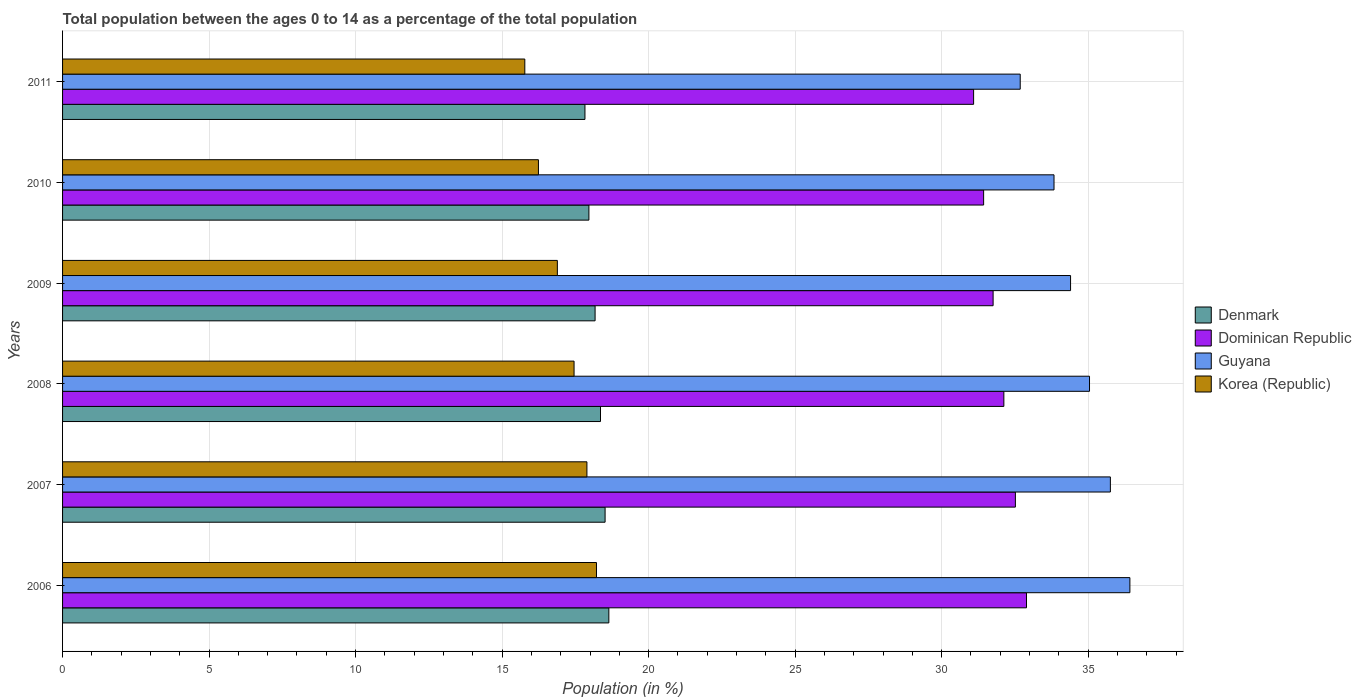Are the number of bars per tick equal to the number of legend labels?
Give a very brief answer. Yes. Are the number of bars on each tick of the Y-axis equal?
Your answer should be very brief. Yes. How many bars are there on the 6th tick from the bottom?
Your response must be concise. 4. What is the percentage of the population ages 0 to 14 in Denmark in 2010?
Make the answer very short. 17.96. Across all years, what is the maximum percentage of the population ages 0 to 14 in Korea (Republic)?
Provide a succinct answer. 18.22. Across all years, what is the minimum percentage of the population ages 0 to 14 in Guyana?
Provide a short and direct response. 32.68. What is the total percentage of the population ages 0 to 14 in Guyana in the graph?
Provide a short and direct response. 208.15. What is the difference between the percentage of the population ages 0 to 14 in Korea (Republic) in 2007 and that in 2010?
Provide a succinct answer. 1.65. What is the difference between the percentage of the population ages 0 to 14 in Dominican Republic in 2010 and the percentage of the population ages 0 to 14 in Korea (Republic) in 2007?
Provide a short and direct response. 13.54. What is the average percentage of the population ages 0 to 14 in Dominican Republic per year?
Your answer should be very brief. 31.97. In the year 2011, what is the difference between the percentage of the population ages 0 to 14 in Denmark and percentage of the population ages 0 to 14 in Guyana?
Keep it short and to the point. -14.85. In how many years, is the percentage of the population ages 0 to 14 in Guyana greater than 1 ?
Your answer should be very brief. 6. What is the ratio of the percentage of the population ages 0 to 14 in Korea (Republic) in 2007 to that in 2010?
Provide a short and direct response. 1.1. Is the difference between the percentage of the population ages 0 to 14 in Denmark in 2008 and 2010 greater than the difference between the percentage of the population ages 0 to 14 in Guyana in 2008 and 2010?
Keep it short and to the point. No. What is the difference between the highest and the second highest percentage of the population ages 0 to 14 in Denmark?
Offer a very short reply. 0.13. What is the difference between the highest and the lowest percentage of the population ages 0 to 14 in Dominican Republic?
Keep it short and to the point. 1.8. In how many years, is the percentage of the population ages 0 to 14 in Korea (Republic) greater than the average percentage of the population ages 0 to 14 in Korea (Republic) taken over all years?
Your response must be concise. 3. Is the sum of the percentage of the population ages 0 to 14 in Denmark in 2006 and 2007 greater than the maximum percentage of the population ages 0 to 14 in Guyana across all years?
Your answer should be very brief. Yes. What does the 1st bar from the top in 2009 represents?
Keep it short and to the point. Korea (Republic). What does the 2nd bar from the bottom in 2009 represents?
Your answer should be very brief. Dominican Republic. Is it the case that in every year, the sum of the percentage of the population ages 0 to 14 in Dominican Republic and percentage of the population ages 0 to 14 in Denmark is greater than the percentage of the population ages 0 to 14 in Korea (Republic)?
Your response must be concise. Yes. How many years are there in the graph?
Provide a short and direct response. 6. What is the difference between two consecutive major ticks on the X-axis?
Your answer should be compact. 5. Does the graph contain any zero values?
Offer a very short reply. No. Where does the legend appear in the graph?
Provide a succinct answer. Center right. How are the legend labels stacked?
Provide a short and direct response. Vertical. What is the title of the graph?
Offer a very short reply. Total population between the ages 0 to 14 as a percentage of the total population. Does "Middle East & North Africa (all income levels)" appear as one of the legend labels in the graph?
Provide a short and direct response. No. What is the label or title of the Y-axis?
Provide a short and direct response. Years. What is the Population (in %) in Denmark in 2006?
Ensure brevity in your answer.  18.64. What is the Population (in %) in Dominican Republic in 2006?
Your response must be concise. 32.9. What is the Population (in %) in Guyana in 2006?
Your answer should be very brief. 36.42. What is the Population (in %) in Korea (Republic) in 2006?
Provide a succinct answer. 18.22. What is the Population (in %) of Denmark in 2007?
Your answer should be compact. 18.52. What is the Population (in %) in Dominican Republic in 2007?
Your answer should be very brief. 32.52. What is the Population (in %) in Guyana in 2007?
Keep it short and to the point. 35.76. What is the Population (in %) in Korea (Republic) in 2007?
Ensure brevity in your answer.  17.89. What is the Population (in %) of Denmark in 2008?
Offer a very short reply. 18.36. What is the Population (in %) in Dominican Republic in 2008?
Give a very brief answer. 32.12. What is the Population (in %) of Guyana in 2008?
Give a very brief answer. 35.05. What is the Population (in %) in Korea (Republic) in 2008?
Offer a terse response. 17.46. What is the Population (in %) in Denmark in 2009?
Your answer should be very brief. 18.17. What is the Population (in %) in Dominican Republic in 2009?
Offer a terse response. 31.76. What is the Population (in %) in Guyana in 2009?
Provide a short and direct response. 34.4. What is the Population (in %) of Korea (Republic) in 2009?
Your response must be concise. 16.89. What is the Population (in %) of Denmark in 2010?
Your response must be concise. 17.96. What is the Population (in %) in Dominican Republic in 2010?
Provide a succinct answer. 31.43. What is the Population (in %) of Guyana in 2010?
Offer a terse response. 33.83. What is the Population (in %) of Korea (Republic) in 2010?
Ensure brevity in your answer.  16.24. What is the Population (in %) of Denmark in 2011?
Your answer should be compact. 17.83. What is the Population (in %) of Dominican Republic in 2011?
Your answer should be compact. 31.09. What is the Population (in %) of Guyana in 2011?
Ensure brevity in your answer.  32.68. What is the Population (in %) of Korea (Republic) in 2011?
Offer a very short reply. 15.77. Across all years, what is the maximum Population (in %) of Denmark?
Your response must be concise. 18.64. Across all years, what is the maximum Population (in %) of Dominican Republic?
Ensure brevity in your answer.  32.9. Across all years, what is the maximum Population (in %) in Guyana?
Offer a terse response. 36.42. Across all years, what is the maximum Population (in %) in Korea (Republic)?
Provide a succinct answer. 18.22. Across all years, what is the minimum Population (in %) of Denmark?
Offer a very short reply. 17.83. Across all years, what is the minimum Population (in %) in Dominican Republic?
Offer a terse response. 31.09. Across all years, what is the minimum Population (in %) in Guyana?
Offer a very short reply. 32.68. Across all years, what is the minimum Population (in %) of Korea (Republic)?
Keep it short and to the point. 15.77. What is the total Population (in %) of Denmark in the graph?
Ensure brevity in your answer.  109.48. What is the total Population (in %) in Dominican Republic in the graph?
Provide a short and direct response. 191.82. What is the total Population (in %) of Guyana in the graph?
Give a very brief answer. 208.15. What is the total Population (in %) in Korea (Republic) in the graph?
Make the answer very short. 102.47. What is the difference between the Population (in %) in Denmark in 2006 and that in 2007?
Provide a succinct answer. 0.13. What is the difference between the Population (in %) of Dominican Republic in 2006 and that in 2007?
Provide a succinct answer. 0.38. What is the difference between the Population (in %) of Guyana in 2006 and that in 2007?
Keep it short and to the point. 0.67. What is the difference between the Population (in %) of Korea (Republic) in 2006 and that in 2007?
Make the answer very short. 0.33. What is the difference between the Population (in %) of Denmark in 2006 and that in 2008?
Offer a very short reply. 0.28. What is the difference between the Population (in %) in Dominican Republic in 2006 and that in 2008?
Give a very brief answer. 0.77. What is the difference between the Population (in %) in Guyana in 2006 and that in 2008?
Ensure brevity in your answer.  1.38. What is the difference between the Population (in %) of Korea (Republic) in 2006 and that in 2008?
Your response must be concise. 0.77. What is the difference between the Population (in %) of Denmark in 2006 and that in 2009?
Provide a short and direct response. 0.47. What is the difference between the Population (in %) of Dominican Republic in 2006 and that in 2009?
Ensure brevity in your answer.  1.14. What is the difference between the Population (in %) in Guyana in 2006 and that in 2009?
Your response must be concise. 2.02. What is the difference between the Population (in %) of Korea (Republic) in 2006 and that in 2009?
Provide a succinct answer. 1.34. What is the difference between the Population (in %) in Denmark in 2006 and that in 2010?
Your answer should be very brief. 0.68. What is the difference between the Population (in %) of Dominican Republic in 2006 and that in 2010?
Your response must be concise. 1.46. What is the difference between the Population (in %) in Guyana in 2006 and that in 2010?
Your answer should be very brief. 2.59. What is the difference between the Population (in %) in Korea (Republic) in 2006 and that in 2010?
Provide a short and direct response. 1.98. What is the difference between the Population (in %) of Denmark in 2006 and that in 2011?
Provide a succinct answer. 0.81. What is the difference between the Population (in %) in Dominican Republic in 2006 and that in 2011?
Make the answer very short. 1.8. What is the difference between the Population (in %) in Guyana in 2006 and that in 2011?
Your response must be concise. 3.74. What is the difference between the Population (in %) of Korea (Republic) in 2006 and that in 2011?
Your answer should be very brief. 2.45. What is the difference between the Population (in %) of Denmark in 2007 and that in 2008?
Keep it short and to the point. 0.16. What is the difference between the Population (in %) of Dominican Republic in 2007 and that in 2008?
Your answer should be very brief. 0.39. What is the difference between the Population (in %) in Guyana in 2007 and that in 2008?
Ensure brevity in your answer.  0.71. What is the difference between the Population (in %) of Korea (Republic) in 2007 and that in 2008?
Your answer should be compact. 0.44. What is the difference between the Population (in %) of Denmark in 2007 and that in 2009?
Provide a succinct answer. 0.34. What is the difference between the Population (in %) of Dominican Republic in 2007 and that in 2009?
Ensure brevity in your answer.  0.76. What is the difference between the Population (in %) of Guyana in 2007 and that in 2009?
Provide a succinct answer. 1.36. What is the difference between the Population (in %) in Korea (Republic) in 2007 and that in 2009?
Ensure brevity in your answer.  1.01. What is the difference between the Population (in %) of Denmark in 2007 and that in 2010?
Offer a very short reply. 0.55. What is the difference between the Population (in %) in Dominican Republic in 2007 and that in 2010?
Give a very brief answer. 1.08. What is the difference between the Population (in %) of Guyana in 2007 and that in 2010?
Your answer should be compact. 1.92. What is the difference between the Population (in %) of Korea (Republic) in 2007 and that in 2010?
Provide a short and direct response. 1.65. What is the difference between the Population (in %) of Denmark in 2007 and that in 2011?
Your answer should be very brief. 0.69. What is the difference between the Population (in %) of Dominican Republic in 2007 and that in 2011?
Make the answer very short. 1.43. What is the difference between the Population (in %) of Guyana in 2007 and that in 2011?
Your response must be concise. 3.08. What is the difference between the Population (in %) in Korea (Republic) in 2007 and that in 2011?
Offer a very short reply. 2.12. What is the difference between the Population (in %) in Denmark in 2008 and that in 2009?
Offer a terse response. 0.18. What is the difference between the Population (in %) in Dominican Republic in 2008 and that in 2009?
Give a very brief answer. 0.37. What is the difference between the Population (in %) of Guyana in 2008 and that in 2009?
Give a very brief answer. 0.65. What is the difference between the Population (in %) of Korea (Republic) in 2008 and that in 2009?
Make the answer very short. 0.57. What is the difference between the Population (in %) in Denmark in 2008 and that in 2010?
Give a very brief answer. 0.4. What is the difference between the Population (in %) of Dominican Republic in 2008 and that in 2010?
Offer a very short reply. 0.69. What is the difference between the Population (in %) in Guyana in 2008 and that in 2010?
Offer a terse response. 1.21. What is the difference between the Population (in %) of Korea (Republic) in 2008 and that in 2010?
Make the answer very short. 1.22. What is the difference between the Population (in %) of Denmark in 2008 and that in 2011?
Ensure brevity in your answer.  0.53. What is the difference between the Population (in %) of Dominican Republic in 2008 and that in 2011?
Give a very brief answer. 1.03. What is the difference between the Population (in %) of Guyana in 2008 and that in 2011?
Provide a short and direct response. 2.36. What is the difference between the Population (in %) in Korea (Republic) in 2008 and that in 2011?
Your response must be concise. 1.68. What is the difference between the Population (in %) of Denmark in 2009 and that in 2010?
Your answer should be very brief. 0.21. What is the difference between the Population (in %) in Dominican Republic in 2009 and that in 2010?
Keep it short and to the point. 0.32. What is the difference between the Population (in %) of Guyana in 2009 and that in 2010?
Offer a terse response. 0.57. What is the difference between the Population (in %) of Korea (Republic) in 2009 and that in 2010?
Offer a very short reply. 0.65. What is the difference between the Population (in %) of Denmark in 2009 and that in 2011?
Your answer should be very brief. 0.35. What is the difference between the Population (in %) in Dominican Republic in 2009 and that in 2011?
Your response must be concise. 0.67. What is the difference between the Population (in %) of Guyana in 2009 and that in 2011?
Give a very brief answer. 1.72. What is the difference between the Population (in %) in Korea (Republic) in 2009 and that in 2011?
Your answer should be compact. 1.11. What is the difference between the Population (in %) in Denmark in 2010 and that in 2011?
Give a very brief answer. 0.13. What is the difference between the Population (in %) of Dominican Republic in 2010 and that in 2011?
Offer a terse response. 0.34. What is the difference between the Population (in %) in Guyana in 2010 and that in 2011?
Offer a very short reply. 1.15. What is the difference between the Population (in %) of Korea (Republic) in 2010 and that in 2011?
Provide a succinct answer. 0.47. What is the difference between the Population (in %) in Denmark in 2006 and the Population (in %) in Dominican Republic in 2007?
Offer a very short reply. -13.87. What is the difference between the Population (in %) of Denmark in 2006 and the Population (in %) of Guyana in 2007?
Provide a succinct answer. -17.12. What is the difference between the Population (in %) of Denmark in 2006 and the Population (in %) of Korea (Republic) in 2007?
Give a very brief answer. 0.75. What is the difference between the Population (in %) in Dominican Republic in 2006 and the Population (in %) in Guyana in 2007?
Make the answer very short. -2.86. What is the difference between the Population (in %) of Dominican Republic in 2006 and the Population (in %) of Korea (Republic) in 2007?
Ensure brevity in your answer.  15. What is the difference between the Population (in %) in Guyana in 2006 and the Population (in %) in Korea (Republic) in 2007?
Provide a succinct answer. 18.53. What is the difference between the Population (in %) of Denmark in 2006 and the Population (in %) of Dominican Republic in 2008?
Make the answer very short. -13.48. What is the difference between the Population (in %) of Denmark in 2006 and the Population (in %) of Guyana in 2008?
Your answer should be very brief. -16.4. What is the difference between the Population (in %) of Denmark in 2006 and the Population (in %) of Korea (Republic) in 2008?
Your answer should be very brief. 1.19. What is the difference between the Population (in %) of Dominican Republic in 2006 and the Population (in %) of Guyana in 2008?
Offer a terse response. -2.15. What is the difference between the Population (in %) in Dominican Republic in 2006 and the Population (in %) in Korea (Republic) in 2008?
Offer a terse response. 15.44. What is the difference between the Population (in %) in Guyana in 2006 and the Population (in %) in Korea (Republic) in 2008?
Make the answer very short. 18.97. What is the difference between the Population (in %) in Denmark in 2006 and the Population (in %) in Dominican Republic in 2009?
Ensure brevity in your answer.  -13.11. What is the difference between the Population (in %) of Denmark in 2006 and the Population (in %) of Guyana in 2009?
Offer a very short reply. -15.76. What is the difference between the Population (in %) of Denmark in 2006 and the Population (in %) of Korea (Republic) in 2009?
Your answer should be very brief. 1.76. What is the difference between the Population (in %) in Dominican Republic in 2006 and the Population (in %) in Guyana in 2009?
Provide a succinct answer. -1.5. What is the difference between the Population (in %) in Dominican Republic in 2006 and the Population (in %) in Korea (Republic) in 2009?
Provide a short and direct response. 16.01. What is the difference between the Population (in %) of Guyana in 2006 and the Population (in %) of Korea (Republic) in 2009?
Offer a very short reply. 19.54. What is the difference between the Population (in %) of Denmark in 2006 and the Population (in %) of Dominican Republic in 2010?
Your response must be concise. -12.79. What is the difference between the Population (in %) of Denmark in 2006 and the Population (in %) of Guyana in 2010?
Make the answer very short. -15.19. What is the difference between the Population (in %) in Denmark in 2006 and the Population (in %) in Korea (Republic) in 2010?
Your answer should be compact. 2.4. What is the difference between the Population (in %) in Dominican Republic in 2006 and the Population (in %) in Guyana in 2010?
Your answer should be very brief. -0.94. What is the difference between the Population (in %) of Dominican Republic in 2006 and the Population (in %) of Korea (Republic) in 2010?
Your answer should be very brief. 16.66. What is the difference between the Population (in %) of Guyana in 2006 and the Population (in %) of Korea (Republic) in 2010?
Provide a short and direct response. 20.18. What is the difference between the Population (in %) of Denmark in 2006 and the Population (in %) of Dominican Republic in 2011?
Provide a succinct answer. -12.45. What is the difference between the Population (in %) of Denmark in 2006 and the Population (in %) of Guyana in 2011?
Offer a very short reply. -14.04. What is the difference between the Population (in %) in Denmark in 2006 and the Population (in %) in Korea (Republic) in 2011?
Offer a terse response. 2.87. What is the difference between the Population (in %) of Dominican Republic in 2006 and the Population (in %) of Guyana in 2011?
Your response must be concise. 0.21. What is the difference between the Population (in %) in Dominican Republic in 2006 and the Population (in %) in Korea (Republic) in 2011?
Offer a very short reply. 17.12. What is the difference between the Population (in %) in Guyana in 2006 and the Population (in %) in Korea (Republic) in 2011?
Provide a succinct answer. 20.65. What is the difference between the Population (in %) in Denmark in 2007 and the Population (in %) in Dominican Republic in 2008?
Your answer should be compact. -13.61. What is the difference between the Population (in %) of Denmark in 2007 and the Population (in %) of Guyana in 2008?
Your answer should be compact. -16.53. What is the difference between the Population (in %) in Denmark in 2007 and the Population (in %) in Korea (Republic) in 2008?
Provide a short and direct response. 1.06. What is the difference between the Population (in %) in Dominican Republic in 2007 and the Population (in %) in Guyana in 2008?
Ensure brevity in your answer.  -2.53. What is the difference between the Population (in %) of Dominican Republic in 2007 and the Population (in %) of Korea (Republic) in 2008?
Make the answer very short. 15.06. What is the difference between the Population (in %) of Guyana in 2007 and the Population (in %) of Korea (Republic) in 2008?
Make the answer very short. 18.3. What is the difference between the Population (in %) in Denmark in 2007 and the Population (in %) in Dominican Republic in 2009?
Provide a short and direct response. -13.24. What is the difference between the Population (in %) of Denmark in 2007 and the Population (in %) of Guyana in 2009?
Your answer should be compact. -15.89. What is the difference between the Population (in %) of Denmark in 2007 and the Population (in %) of Korea (Republic) in 2009?
Give a very brief answer. 1.63. What is the difference between the Population (in %) in Dominican Republic in 2007 and the Population (in %) in Guyana in 2009?
Your answer should be compact. -1.88. What is the difference between the Population (in %) of Dominican Republic in 2007 and the Population (in %) of Korea (Republic) in 2009?
Ensure brevity in your answer.  15.63. What is the difference between the Population (in %) in Guyana in 2007 and the Population (in %) in Korea (Republic) in 2009?
Keep it short and to the point. 18.87. What is the difference between the Population (in %) of Denmark in 2007 and the Population (in %) of Dominican Republic in 2010?
Provide a succinct answer. -12.92. What is the difference between the Population (in %) in Denmark in 2007 and the Population (in %) in Guyana in 2010?
Give a very brief answer. -15.32. What is the difference between the Population (in %) of Denmark in 2007 and the Population (in %) of Korea (Republic) in 2010?
Keep it short and to the point. 2.27. What is the difference between the Population (in %) of Dominican Republic in 2007 and the Population (in %) of Guyana in 2010?
Give a very brief answer. -1.32. What is the difference between the Population (in %) in Dominican Republic in 2007 and the Population (in %) in Korea (Republic) in 2010?
Your answer should be compact. 16.28. What is the difference between the Population (in %) in Guyana in 2007 and the Population (in %) in Korea (Republic) in 2010?
Keep it short and to the point. 19.52. What is the difference between the Population (in %) of Denmark in 2007 and the Population (in %) of Dominican Republic in 2011?
Provide a succinct answer. -12.58. What is the difference between the Population (in %) in Denmark in 2007 and the Population (in %) in Guyana in 2011?
Provide a short and direct response. -14.17. What is the difference between the Population (in %) of Denmark in 2007 and the Population (in %) of Korea (Republic) in 2011?
Offer a very short reply. 2.74. What is the difference between the Population (in %) in Dominican Republic in 2007 and the Population (in %) in Guyana in 2011?
Provide a succinct answer. -0.16. What is the difference between the Population (in %) in Dominican Republic in 2007 and the Population (in %) in Korea (Republic) in 2011?
Offer a very short reply. 16.74. What is the difference between the Population (in %) in Guyana in 2007 and the Population (in %) in Korea (Republic) in 2011?
Keep it short and to the point. 19.98. What is the difference between the Population (in %) in Denmark in 2008 and the Population (in %) in Dominican Republic in 2009?
Your answer should be very brief. -13.4. What is the difference between the Population (in %) in Denmark in 2008 and the Population (in %) in Guyana in 2009?
Ensure brevity in your answer.  -16.04. What is the difference between the Population (in %) of Denmark in 2008 and the Population (in %) of Korea (Republic) in 2009?
Offer a terse response. 1.47. What is the difference between the Population (in %) in Dominican Republic in 2008 and the Population (in %) in Guyana in 2009?
Make the answer very short. -2.28. What is the difference between the Population (in %) of Dominican Republic in 2008 and the Population (in %) of Korea (Republic) in 2009?
Offer a very short reply. 15.24. What is the difference between the Population (in %) of Guyana in 2008 and the Population (in %) of Korea (Republic) in 2009?
Provide a succinct answer. 18.16. What is the difference between the Population (in %) in Denmark in 2008 and the Population (in %) in Dominican Republic in 2010?
Your answer should be compact. -13.07. What is the difference between the Population (in %) in Denmark in 2008 and the Population (in %) in Guyana in 2010?
Your answer should be compact. -15.48. What is the difference between the Population (in %) of Denmark in 2008 and the Population (in %) of Korea (Republic) in 2010?
Provide a succinct answer. 2.12. What is the difference between the Population (in %) in Dominican Republic in 2008 and the Population (in %) in Guyana in 2010?
Offer a very short reply. -1.71. What is the difference between the Population (in %) of Dominican Republic in 2008 and the Population (in %) of Korea (Republic) in 2010?
Make the answer very short. 15.88. What is the difference between the Population (in %) of Guyana in 2008 and the Population (in %) of Korea (Republic) in 2010?
Keep it short and to the point. 18.81. What is the difference between the Population (in %) in Denmark in 2008 and the Population (in %) in Dominican Republic in 2011?
Provide a succinct answer. -12.73. What is the difference between the Population (in %) of Denmark in 2008 and the Population (in %) of Guyana in 2011?
Your response must be concise. -14.32. What is the difference between the Population (in %) in Denmark in 2008 and the Population (in %) in Korea (Republic) in 2011?
Ensure brevity in your answer.  2.58. What is the difference between the Population (in %) of Dominican Republic in 2008 and the Population (in %) of Guyana in 2011?
Offer a very short reply. -0.56. What is the difference between the Population (in %) of Dominican Republic in 2008 and the Population (in %) of Korea (Republic) in 2011?
Keep it short and to the point. 16.35. What is the difference between the Population (in %) of Guyana in 2008 and the Population (in %) of Korea (Republic) in 2011?
Give a very brief answer. 19.27. What is the difference between the Population (in %) of Denmark in 2009 and the Population (in %) of Dominican Republic in 2010?
Your response must be concise. -13.26. What is the difference between the Population (in %) in Denmark in 2009 and the Population (in %) in Guyana in 2010?
Make the answer very short. -15.66. What is the difference between the Population (in %) of Denmark in 2009 and the Population (in %) of Korea (Republic) in 2010?
Keep it short and to the point. 1.93. What is the difference between the Population (in %) in Dominican Republic in 2009 and the Population (in %) in Guyana in 2010?
Ensure brevity in your answer.  -2.08. What is the difference between the Population (in %) of Dominican Republic in 2009 and the Population (in %) of Korea (Republic) in 2010?
Make the answer very short. 15.52. What is the difference between the Population (in %) of Guyana in 2009 and the Population (in %) of Korea (Republic) in 2010?
Provide a short and direct response. 18.16. What is the difference between the Population (in %) in Denmark in 2009 and the Population (in %) in Dominican Republic in 2011?
Offer a terse response. -12.92. What is the difference between the Population (in %) in Denmark in 2009 and the Population (in %) in Guyana in 2011?
Your answer should be very brief. -14.51. What is the difference between the Population (in %) of Denmark in 2009 and the Population (in %) of Korea (Republic) in 2011?
Ensure brevity in your answer.  2.4. What is the difference between the Population (in %) of Dominican Republic in 2009 and the Population (in %) of Guyana in 2011?
Your answer should be very brief. -0.93. What is the difference between the Population (in %) in Dominican Republic in 2009 and the Population (in %) in Korea (Republic) in 2011?
Provide a short and direct response. 15.98. What is the difference between the Population (in %) of Guyana in 2009 and the Population (in %) of Korea (Republic) in 2011?
Provide a succinct answer. 18.63. What is the difference between the Population (in %) in Denmark in 2010 and the Population (in %) in Dominican Republic in 2011?
Your answer should be very brief. -13.13. What is the difference between the Population (in %) of Denmark in 2010 and the Population (in %) of Guyana in 2011?
Your response must be concise. -14.72. What is the difference between the Population (in %) in Denmark in 2010 and the Population (in %) in Korea (Republic) in 2011?
Provide a succinct answer. 2.19. What is the difference between the Population (in %) of Dominican Republic in 2010 and the Population (in %) of Guyana in 2011?
Ensure brevity in your answer.  -1.25. What is the difference between the Population (in %) in Dominican Republic in 2010 and the Population (in %) in Korea (Republic) in 2011?
Provide a succinct answer. 15.66. What is the difference between the Population (in %) in Guyana in 2010 and the Population (in %) in Korea (Republic) in 2011?
Ensure brevity in your answer.  18.06. What is the average Population (in %) of Denmark per year?
Give a very brief answer. 18.25. What is the average Population (in %) in Dominican Republic per year?
Your response must be concise. 31.97. What is the average Population (in %) in Guyana per year?
Offer a very short reply. 34.69. What is the average Population (in %) in Korea (Republic) per year?
Your answer should be compact. 17.08. In the year 2006, what is the difference between the Population (in %) of Denmark and Population (in %) of Dominican Republic?
Offer a very short reply. -14.25. In the year 2006, what is the difference between the Population (in %) of Denmark and Population (in %) of Guyana?
Give a very brief answer. -17.78. In the year 2006, what is the difference between the Population (in %) in Denmark and Population (in %) in Korea (Republic)?
Give a very brief answer. 0.42. In the year 2006, what is the difference between the Population (in %) of Dominican Republic and Population (in %) of Guyana?
Ensure brevity in your answer.  -3.53. In the year 2006, what is the difference between the Population (in %) of Dominican Republic and Population (in %) of Korea (Republic)?
Ensure brevity in your answer.  14.68. In the year 2006, what is the difference between the Population (in %) in Guyana and Population (in %) in Korea (Republic)?
Make the answer very short. 18.2. In the year 2007, what is the difference between the Population (in %) in Denmark and Population (in %) in Dominican Republic?
Give a very brief answer. -14. In the year 2007, what is the difference between the Population (in %) of Denmark and Population (in %) of Guyana?
Keep it short and to the point. -17.24. In the year 2007, what is the difference between the Population (in %) in Denmark and Population (in %) in Korea (Republic)?
Offer a very short reply. 0.62. In the year 2007, what is the difference between the Population (in %) in Dominican Republic and Population (in %) in Guyana?
Your answer should be very brief. -3.24. In the year 2007, what is the difference between the Population (in %) of Dominican Republic and Population (in %) of Korea (Republic)?
Keep it short and to the point. 14.62. In the year 2007, what is the difference between the Population (in %) in Guyana and Population (in %) in Korea (Republic)?
Your answer should be compact. 17.86. In the year 2008, what is the difference between the Population (in %) of Denmark and Population (in %) of Dominican Republic?
Offer a very short reply. -13.77. In the year 2008, what is the difference between the Population (in %) of Denmark and Population (in %) of Guyana?
Provide a short and direct response. -16.69. In the year 2008, what is the difference between the Population (in %) in Denmark and Population (in %) in Korea (Republic)?
Give a very brief answer. 0.9. In the year 2008, what is the difference between the Population (in %) in Dominican Republic and Population (in %) in Guyana?
Keep it short and to the point. -2.92. In the year 2008, what is the difference between the Population (in %) of Dominican Republic and Population (in %) of Korea (Republic)?
Provide a short and direct response. 14.67. In the year 2008, what is the difference between the Population (in %) in Guyana and Population (in %) in Korea (Republic)?
Offer a terse response. 17.59. In the year 2009, what is the difference between the Population (in %) of Denmark and Population (in %) of Dominican Republic?
Ensure brevity in your answer.  -13.58. In the year 2009, what is the difference between the Population (in %) in Denmark and Population (in %) in Guyana?
Your response must be concise. -16.23. In the year 2009, what is the difference between the Population (in %) in Denmark and Population (in %) in Korea (Republic)?
Your answer should be very brief. 1.29. In the year 2009, what is the difference between the Population (in %) in Dominican Republic and Population (in %) in Guyana?
Offer a very short reply. -2.64. In the year 2009, what is the difference between the Population (in %) of Dominican Republic and Population (in %) of Korea (Republic)?
Provide a succinct answer. 14.87. In the year 2009, what is the difference between the Population (in %) in Guyana and Population (in %) in Korea (Republic)?
Offer a terse response. 17.51. In the year 2010, what is the difference between the Population (in %) of Denmark and Population (in %) of Dominican Republic?
Ensure brevity in your answer.  -13.47. In the year 2010, what is the difference between the Population (in %) of Denmark and Population (in %) of Guyana?
Your response must be concise. -15.87. In the year 2010, what is the difference between the Population (in %) in Denmark and Population (in %) in Korea (Republic)?
Keep it short and to the point. 1.72. In the year 2010, what is the difference between the Population (in %) of Dominican Republic and Population (in %) of Guyana?
Provide a succinct answer. -2.4. In the year 2010, what is the difference between the Population (in %) of Dominican Republic and Population (in %) of Korea (Republic)?
Ensure brevity in your answer.  15.19. In the year 2010, what is the difference between the Population (in %) in Guyana and Population (in %) in Korea (Republic)?
Your answer should be compact. 17.59. In the year 2011, what is the difference between the Population (in %) in Denmark and Population (in %) in Dominican Republic?
Your answer should be very brief. -13.26. In the year 2011, what is the difference between the Population (in %) of Denmark and Population (in %) of Guyana?
Give a very brief answer. -14.85. In the year 2011, what is the difference between the Population (in %) of Denmark and Population (in %) of Korea (Republic)?
Offer a very short reply. 2.05. In the year 2011, what is the difference between the Population (in %) in Dominican Republic and Population (in %) in Guyana?
Ensure brevity in your answer.  -1.59. In the year 2011, what is the difference between the Population (in %) in Dominican Republic and Population (in %) in Korea (Republic)?
Ensure brevity in your answer.  15.32. In the year 2011, what is the difference between the Population (in %) in Guyana and Population (in %) in Korea (Republic)?
Give a very brief answer. 16.91. What is the ratio of the Population (in %) in Denmark in 2006 to that in 2007?
Provide a short and direct response. 1.01. What is the ratio of the Population (in %) of Dominican Republic in 2006 to that in 2007?
Offer a very short reply. 1.01. What is the ratio of the Population (in %) of Guyana in 2006 to that in 2007?
Your answer should be very brief. 1.02. What is the ratio of the Population (in %) in Korea (Republic) in 2006 to that in 2007?
Your answer should be compact. 1.02. What is the ratio of the Population (in %) of Denmark in 2006 to that in 2008?
Your answer should be very brief. 1.02. What is the ratio of the Population (in %) in Dominican Republic in 2006 to that in 2008?
Keep it short and to the point. 1.02. What is the ratio of the Population (in %) of Guyana in 2006 to that in 2008?
Make the answer very short. 1.04. What is the ratio of the Population (in %) of Korea (Republic) in 2006 to that in 2008?
Keep it short and to the point. 1.04. What is the ratio of the Population (in %) of Denmark in 2006 to that in 2009?
Keep it short and to the point. 1.03. What is the ratio of the Population (in %) of Dominican Republic in 2006 to that in 2009?
Give a very brief answer. 1.04. What is the ratio of the Population (in %) of Guyana in 2006 to that in 2009?
Offer a terse response. 1.06. What is the ratio of the Population (in %) in Korea (Republic) in 2006 to that in 2009?
Ensure brevity in your answer.  1.08. What is the ratio of the Population (in %) in Denmark in 2006 to that in 2010?
Provide a succinct answer. 1.04. What is the ratio of the Population (in %) in Dominican Republic in 2006 to that in 2010?
Ensure brevity in your answer.  1.05. What is the ratio of the Population (in %) of Guyana in 2006 to that in 2010?
Offer a very short reply. 1.08. What is the ratio of the Population (in %) in Korea (Republic) in 2006 to that in 2010?
Your response must be concise. 1.12. What is the ratio of the Population (in %) of Denmark in 2006 to that in 2011?
Your response must be concise. 1.05. What is the ratio of the Population (in %) of Dominican Republic in 2006 to that in 2011?
Keep it short and to the point. 1.06. What is the ratio of the Population (in %) of Guyana in 2006 to that in 2011?
Your response must be concise. 1.11. What is the ratio of the Population (in %) in Korea (Republic) in 2006 to that in 2011?
Offer a terse response. 1.16. What is the ratio of the Population (in %) of Denmark in 2007 to that in 2008?
Give a very brief answer. 1.01. What is the ratio of the Population (in %) in Dominican Republic in 2007 to that in 2008?
Make the answer very short. 1.01. What is the ratio of the Population (in %) in Guyana in 2007 to that in 2008?
Give a very brief answer. 1.02. What is the ratio of the Population (in %) in Korea (Republic) in 2007 to that in 2008?
Your answer should be compact. 1.03. What is the ratio of the Population (in %) in Denmark in 2007 to that in 2009?
Your answer should be compact. 1.02. What is the ratio of the Population (in %) of Dominican Republic in 2007 to that in 2009?
Give a very brief answer. 1.02. What is the ratio of the Population (in %) in Guyana in 2007 to that in 2009?
Your answer should be very brief. 1.04. What is the ratio of the Population (in %) of Korea (Republic) in 2007 to that in 2009?
Provide a short and direct response. 1.06. What is the ratio of the Population (in %) of Denmark in 2007 to that in 2010?
Keep it short and to the point. 1.03. What is the ratio of the Population (in %) of Dominican Republic in 2007 to that in 2010?
Ensure brevity in your answer.  1.03. What is the ratio of the Population (in %) in Guyana in 2007 to that in 2010?
Make the answer very short. 1.06. What is the ratio of the Population (in %) of Korea (Republic) in 2007 to that in 2010?
Make the answer very short. 1.1. What is the ratio of the Population (in %) in Denmark in 2007 to that in 2011?
Keep it short and to the point. 1.04. What is the ratio of the Population (in %) in Dominican Republic in 2007 to that in 2011?
Your response must be concise. 1.05. What is the ratio of the Population (in %) of Guyana in 2007 to that in 2011?
Offer a very short reply. 1.09. What is the ratio of the Population (in %) in Korea (Republic) in 2007 to that in 2011?
Keep it short and to the point. 1.13. What is the ratio of the Population (in %) of Dominican Republic in 2008 to that in 2009?
Offer a very short reply. 1.01. What is the ratio of the Population (in %) in Guyana in 2008 to that in 2009?
Offer a very short reply. 1.02. What is the ratio of the Population (in %) of Korea (Republic) in 2008 to that in 2009?
Offer a terse response. 1.03. What is the ratio of the Population (in %) in Guyana in 2008 to that in 2010?
Your response must be concise. 1.04. What is the ratio of the Population (in %) in Korea (Republic) in 2008 to that in 2010?
Provide a short and direct response. 1.07. What is the ratio of the Population (in %) of Denmark in 2008 to that in 2011?
Offer a very short reply. 1.03. What is the ratio of the Population (in %) of Dominican Republic in 2008 to that in 2011?
Ensure brevity in your answer.  1.03. What is the ratio of the Population (in %) of Guyana in 2008 to that in 2011?
Give a very brief answer. 1.07. What is the ratio of the Population (in %) of Korea (Republic) in 2008 to that in 2011?
Offer a terse response. 1.11. What is the ratio of the Population (in %) of Denmark in 2009 to that in 2010?
Your answer should be very brief. 1.01. What is the ratio of the Population (in %) of Dominican Republic in 2009 to that in 2010?
Keep it short and to the point. 1.01. What is the ratio of the Population (in %) in Guyana in 2009 to that in 2010?
Make the answer very short. 1.02. What is the ratio of the Population (in %) in Korea (Republic) in 2009 to that in 2010?
Offer a very short reply. 1.04. What is the ratio of the Population (in %) of Denmark in 2009 to that in 2011?
Keep it short and to the point. 1.02. What is the ratio of the Population (in %) in Dominican Republic in 2009 to that in 2011?
Offer a very short reply. 1.02. What is the ratio of the Population (in %) of Guyana in 2009 to that in 2011?
Offer a terse response. 1.05. What is the ratio of the Population (in %) of Korea (Republic) in 2009 to that in 2011?
Offer a terse response. 1.07. What is the ratio of the Population (in %) of Denmark in 2010 to that in 2011?
Offer a very short reply. 1.01. What is the ratio of the Population (in %) in Dominican Republic in 2010 to that in 2011?
Offer a terse response. 1.01. What is the ratio of the Population (in %) in Guyana in 2010 to that in 2011?
Offer a very short reply. 1.04. What is the ratio of the Population (in %) of Korea (Republic) in 2010 to that in 2011?
Ensure brevity in your answer.  1.03. What is the difference between the highest and the second highest Population (in %) in Denmark?
Your answer should be compact. 0.13. What is the difference between the highest and the second highest Population (in %) in Dominican Republic?
Keep it short and to the point. 0.38. What is the difference between the highest and the second highest Population (in %) in Guyana?
Your answer should be compact. 0.67. What is the difference between the highest and the second highest Population (in %) of Korea (Republic)?
Keep it short and to the point. 0.33. What is the difference between the highest and the lowest Population (in %) of Denmark?
Provide a succinct answer. 0.81. What is the difference between the highest and the lowest Population (in %) of Dominican Republic?
Your response must be concise. 1.8. What is the difference between the highest and the lowest Population (in %) in Guyana?
Keep it short and to the point. 3.74. What is the difference between the highest and the lowest Population (in %) in Korea (Republic)?
Your response must be concise. 2.45. 